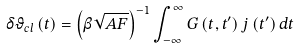Convert formula to latex. <formula><loc_0><loc_0><loc_500><loc_500>\delta \vartheta _ { c l } \left ( t \right ) = \left ( \beta \sqrt { A F } \right ) ^ { - 1 } \int _ { - \infty } ^ { \infty } G \left ( t , t ^ { \prime } \right ) j \left ( t ^ { \prime } \right ) d t</formula> 